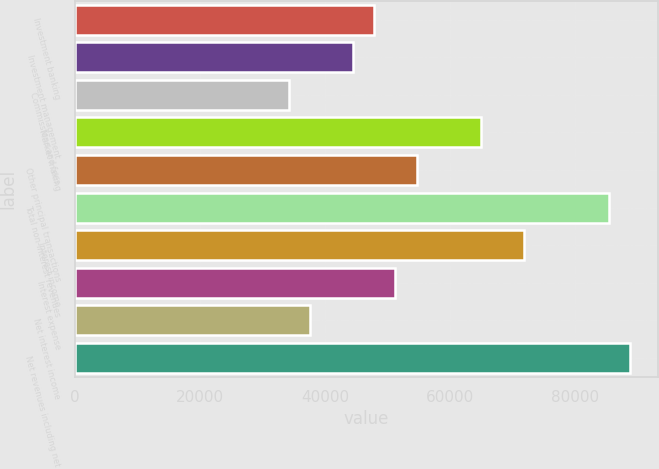Convert chart. <chart><loc_0><loc_0><loc_500><loc_500><bar_chart><fcel>Investment banking<fcel>Investment management<fcel>Commissions and fees<fcel>Market making<fcel>Other principal transactions<fcel>Total non-interest revenues<fcel>Interest income<fcel>Interest expense<fcel>Net interest income<fcel>Net revenues including net<nl><fcel>47882.2<fcel>44463.1<fcel>34206<fcel>64977.4<fcel>54720.3<fcel>85491.7<fcel>71815.5<fcel>51301.2<fcel>37625<fcel>88910.8<nl></chart> 